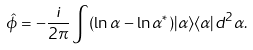Convert formula to latex. <formula><loc_0><loc_0><loc_500><loc_500>\hat { \phi } = - \frac { i } { 2 \pi } \int ( \ln \alpha - \ln \alpha ^ { * } ) | \alpha \rangle \langle \alpha | d ^ { 2 } \alpha .</formula> 